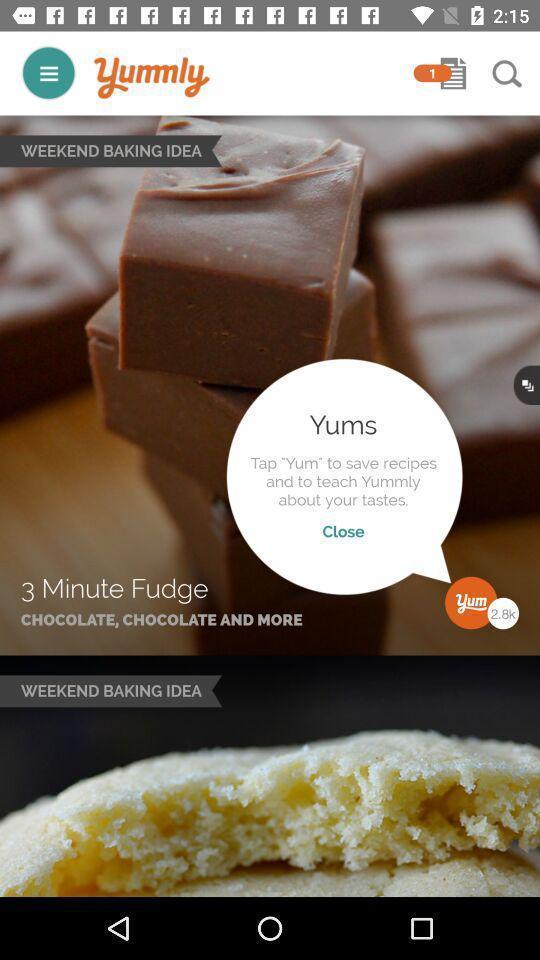What details can you identify in this image? Screen page of a food application. 